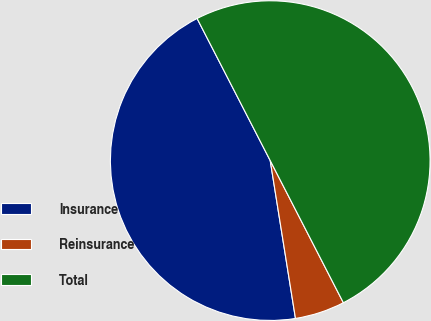Convert chart. <chart><loc_0><loc_0><loc_500><loc_500><pie_chart><fcel>Insurance<fcel>Reinsurance<fcel>Total<nl><fcel>44.96%<fcel>5.04%<fcel>50.0%<nl></chart> 